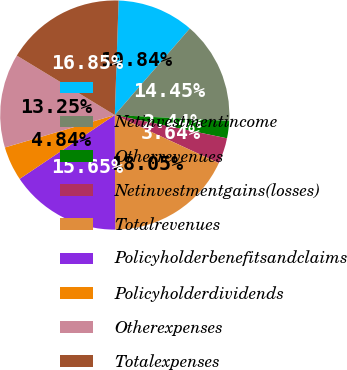<chart> <loc_0><loc_0><loc_500><loc_500><pie_chart><ecel><fcel>Netinvestmentincome<fcel>Otherrevenues<fcel>Netinvestmentgains(losses)<fcel>Totalrevenues<fcel>Policyholderbenefitsandclaims<fcel>Policyholderdividends<fcel>Otherexpenses<fcel>Totalexpenses<nl><fcel>10.84%<fcel>14.45%<fcel>2.44%<fcel>3.64%<fcel>18.05%<fcel>15.65%<fcel>4.84%<fcel>13.25%<fcel>16.85%<nl></chart> 